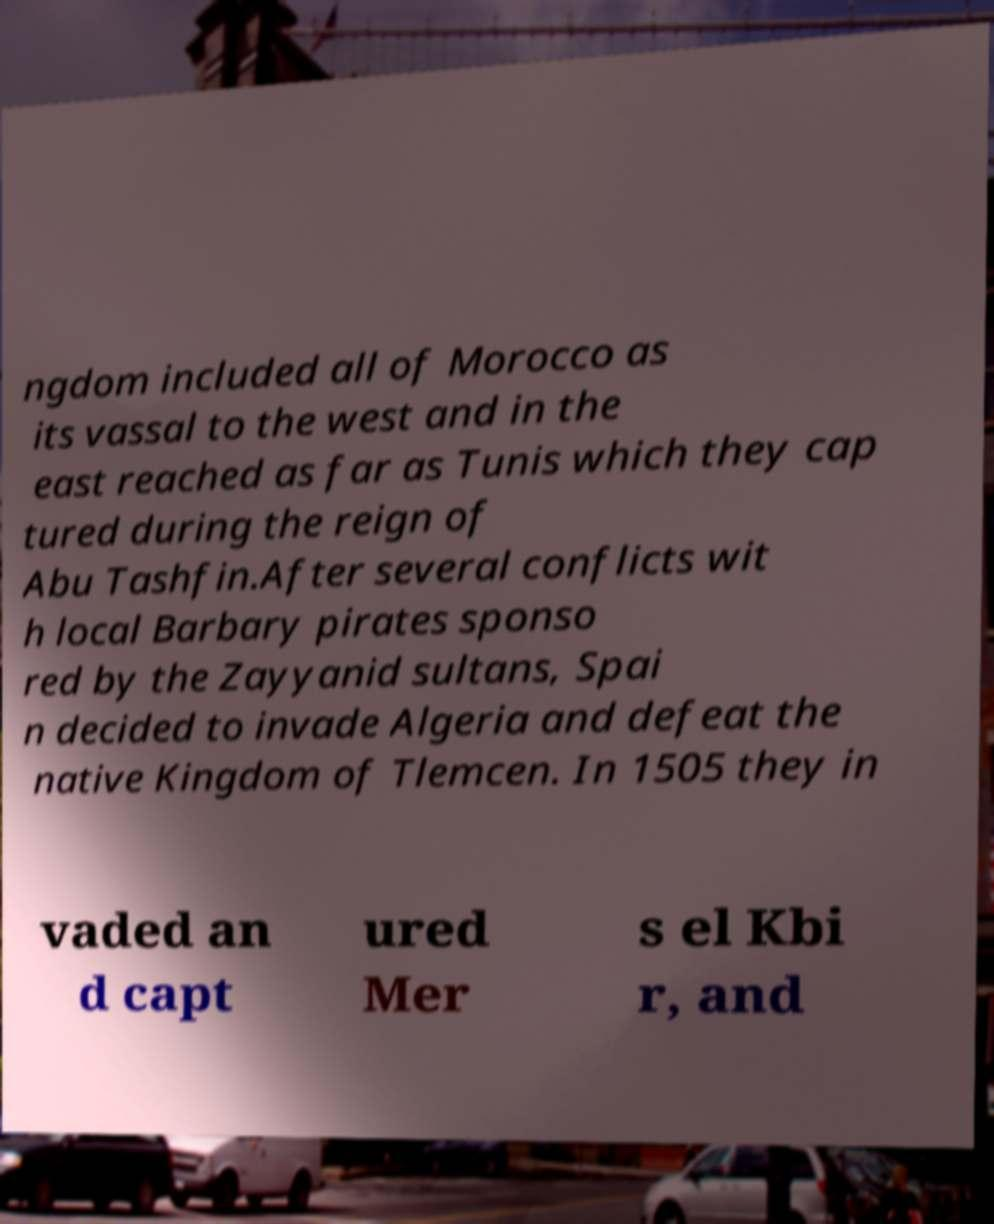Please read and relay the text visible in this image. What does it say? ngdom included all of Morocco as its vassal to the west and in the east reached as far as Tunis which they cap tured during the reign of Abu Tashfin.After several conflicts wit h local Barbary pirates sponso red by the Zayyanid sultans, Spai n decided to invade Algeria and defeat the native Kingdom of Tlemcen. In 1505 they in vaded an d capt ured Mer s el Kbi r, and 